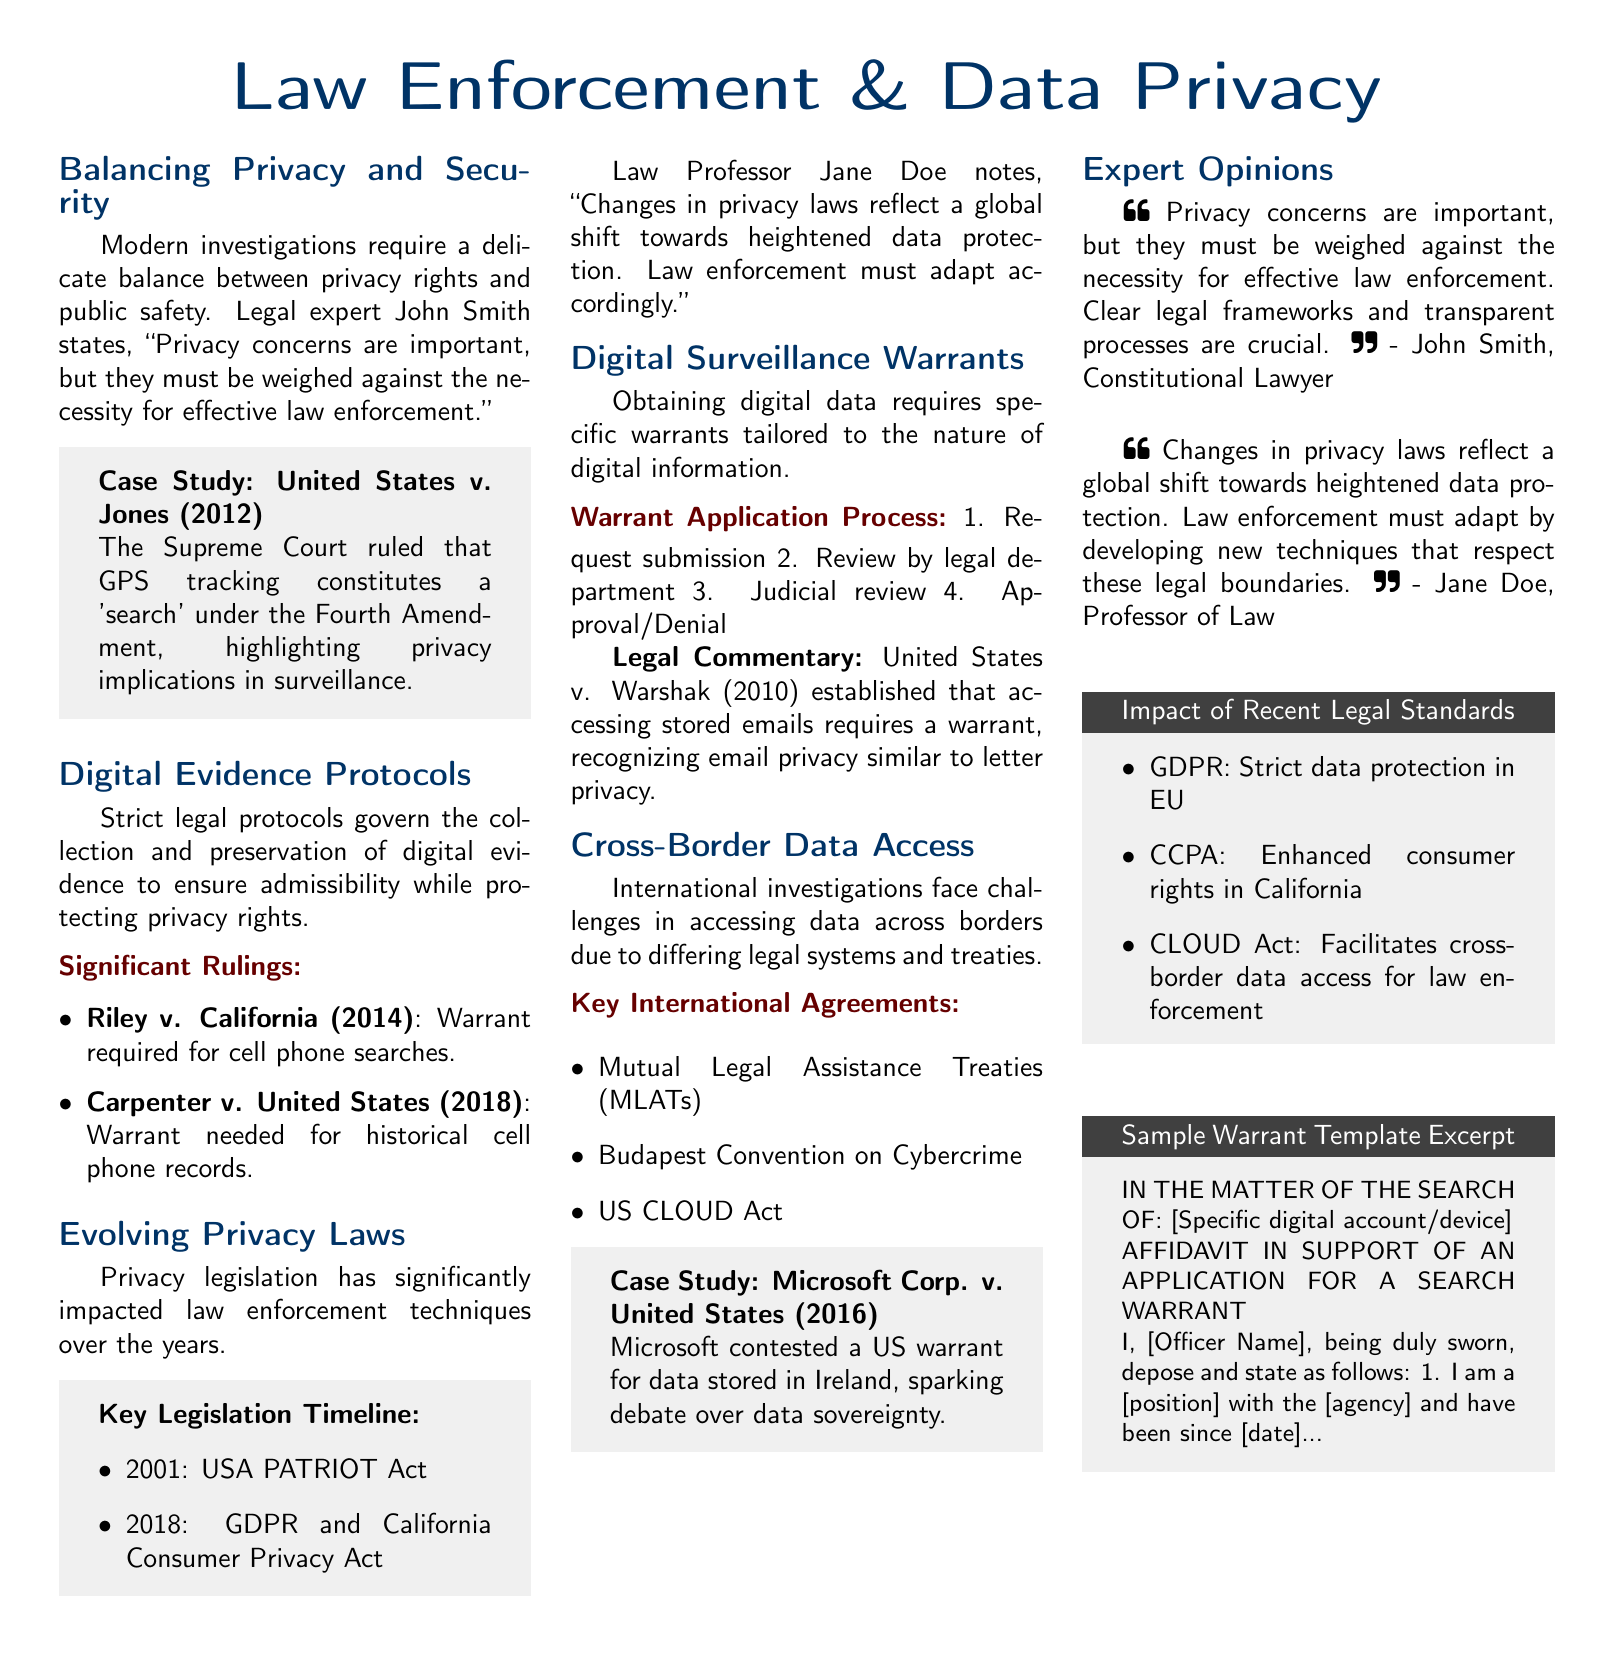What is the title of the article? The title of the article is the primary headline found at the top of the document.
Answer: Law Enforcement & Data Privacy Who is the legal expert mentioned? The legal expert is quoted directly in the section on balancing privacy and security.
Answer: John Smith What year was the USA PATRIOT Act enacted? The timeline section lists key legislation along with their enactment years.
Answer: 2001 Which case established that accessing stored emails requires a warrant? In the digital surveillance warrants section, this case is highlighted with legal commentary.
Answer: United States v. Warshak What is one of the key international agreements mentioned? The cross-border data access section mentions several agreements relevant to international law enforcement.
Answer: Mutual Legal Assistance Treaties (MLATs) What recent law facilitates cross-border data access for law enforcement? The impact of recent legal standards section lists significant laws with their purpose.
Answer: CLOUD Act What are the first two steps in the warrant application process? The warrant application process is outlined in a numbered list, detailing the sequential steps involved.
Answer: Request submission, Review by legal department What is the implication of the ruling in United States v. Jones? The case study discusses privacy implications related to surveillance in the context of a Supreme Court ruling.
Answer: GPS tracking constitutes a 'search' What does John Smith emphasize about privacy concerns? The expert opinions section features direct quotes from legal experts, highlighting their views.
Answer: Weighed against the necessity for effective law enforcement 